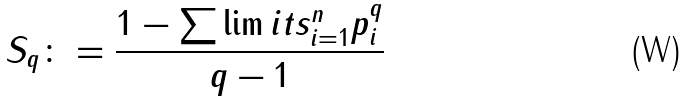Convert formula to latex. <formula><loc_0><loc_0><loc_500><loc_500>S _ { q } \colon = \frac { 1 - \sum \lim i t s _ { i = 1 } ^ { n } p _ { i } ^ { q } } { q - 1 }</formula> 